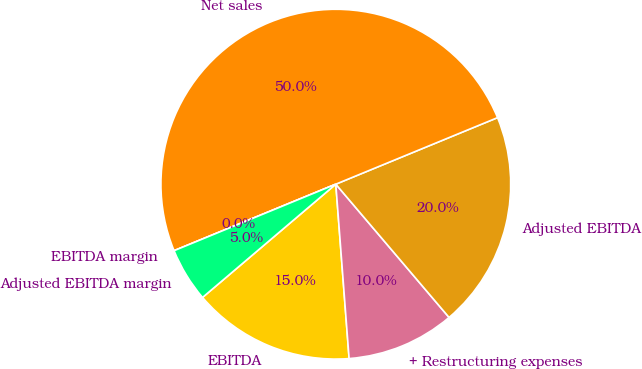Convert chart. <chart><loc_0><loc_0><loc_500><loc_500><pie_chart><fcel>EBITDA<fcel>+ Restructuring expenses<fcel>Adjusted EBITDA<fcel>Net sales<fcel>EBITDA margin<fcel>Adjusted EBITDA margin<nl><fcel>15.0%<fcel>10.0%<fcel>20.0%<fcel>50.0%<fcel>0.0%<fcel>5.0%<nl></chart> 